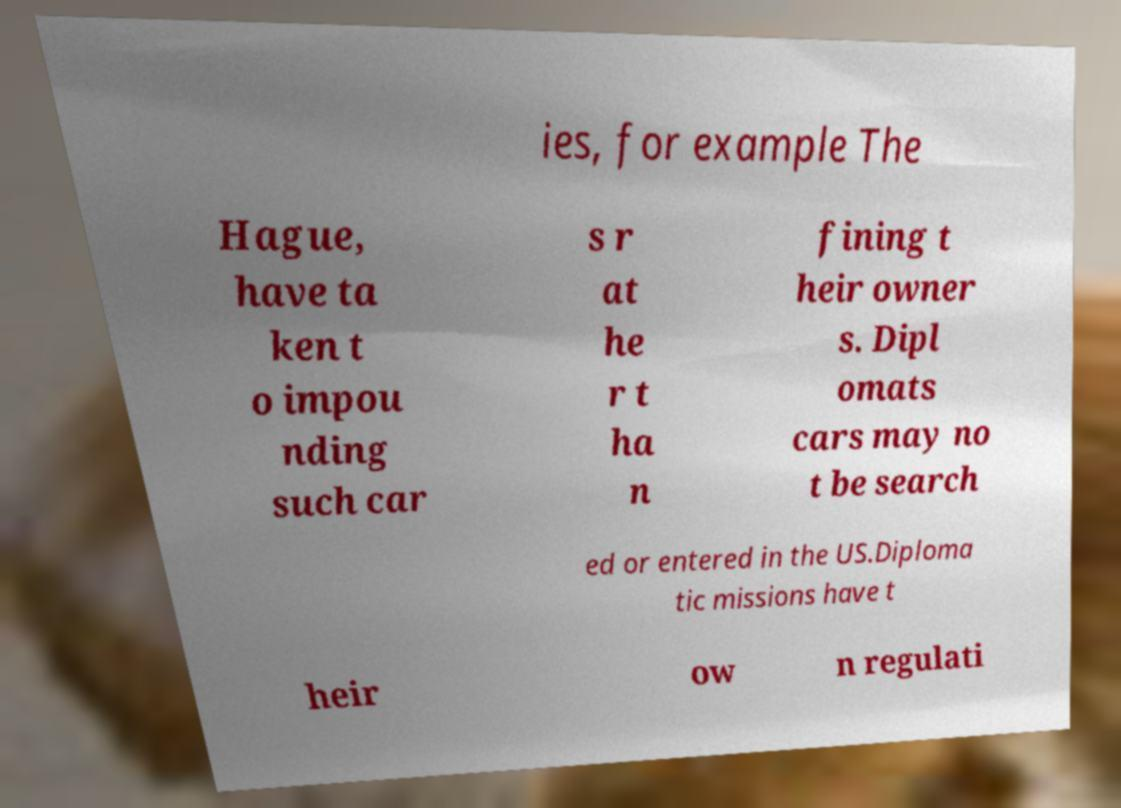Can you accurately transcribe the text from the provided image for me? ies, for example The Hague, have ta ken t o impou nding such car s r at he r t ha n fining t heir owner s. Dipl omats cars may no t be search ed or entered in the US.Diploma tic missions have t heir ow n regulati 